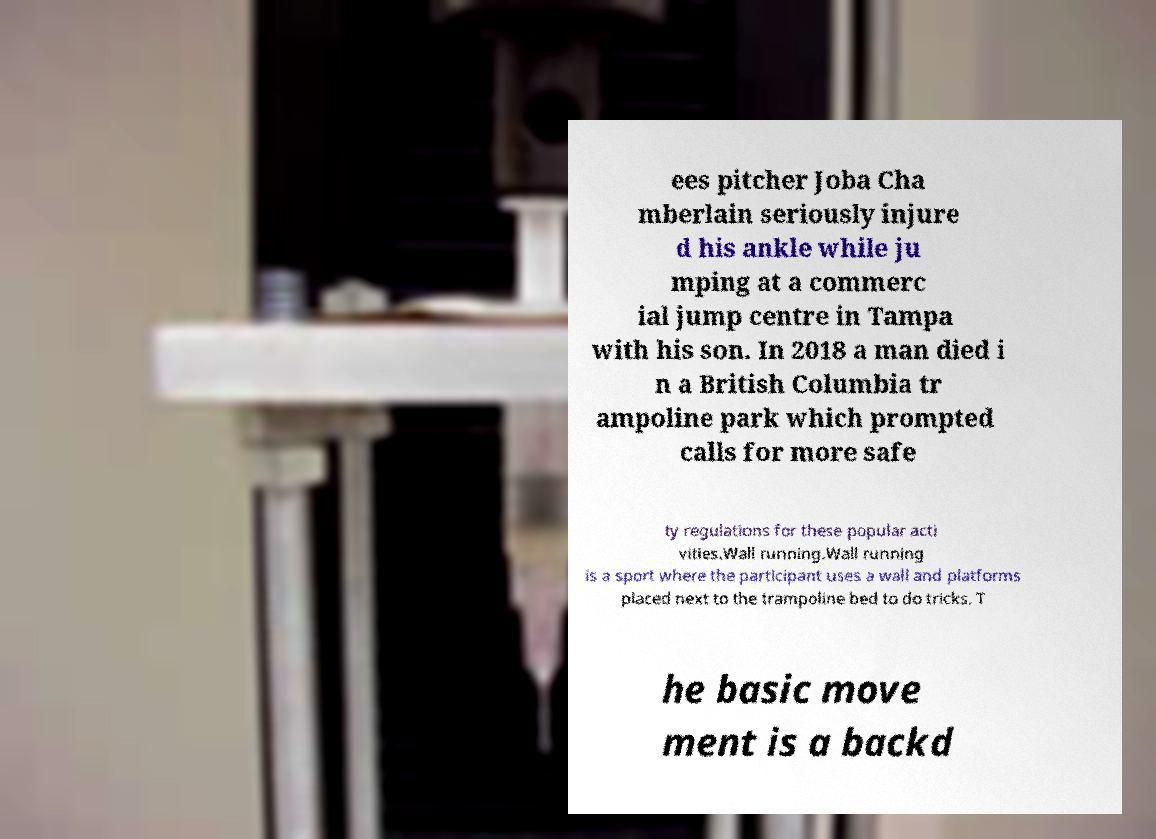Can you read and provide the text displayed in the image?This photo seems to have some interesting text. Can you extract and type it out for me? ees pitcher Joba Cha mberlain seriously injure d his ankle while ju mping at a commerc ial jump centre in Tampa with his son. In 2018 a man died i n a British Columbia tr ampoline park which prompted calls for more safe ty regulations for these popular acti vities.Wall running.Wall running is a sport where the participant uses a wall and platforms placed next to the trampoline bed to do tricks. T he basic move ment is a backd 